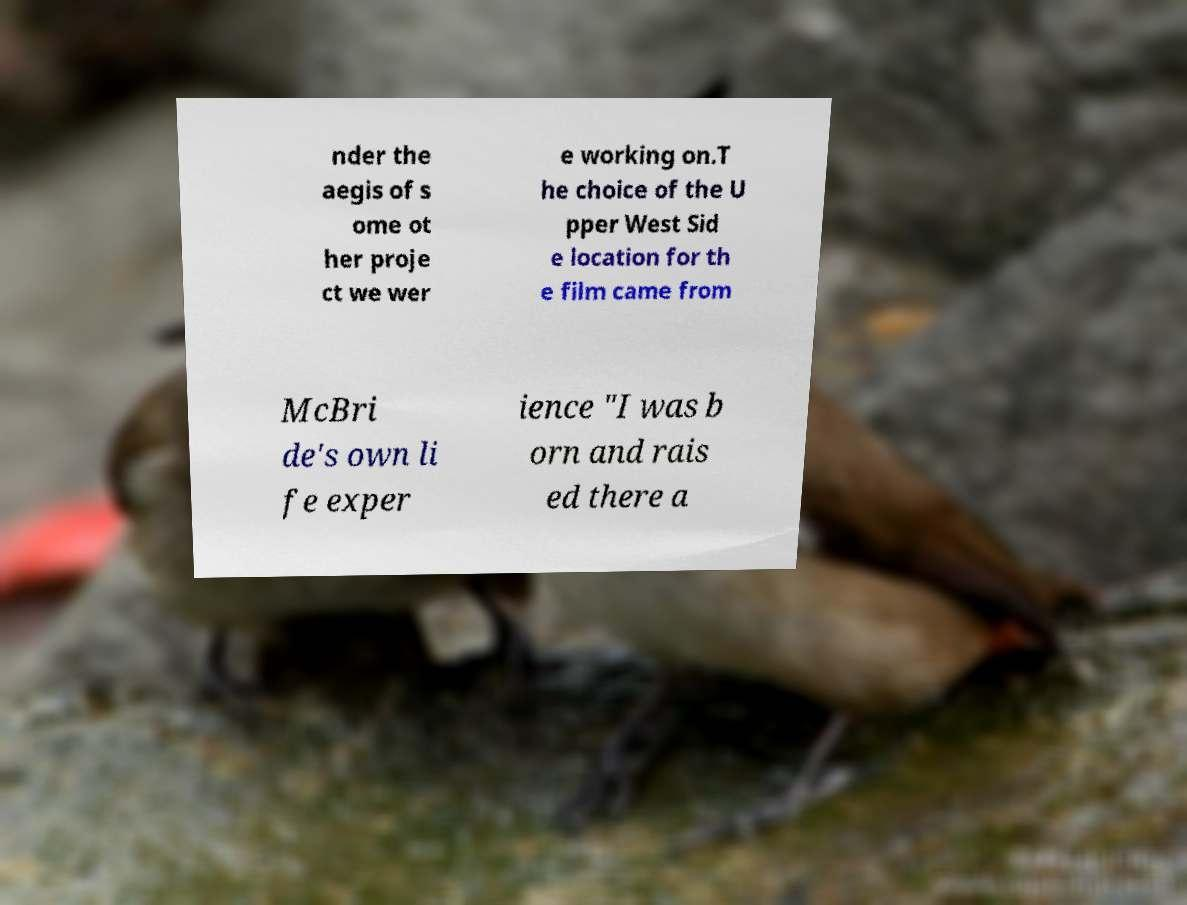I need the written content from this picture converted into text. Can you do that? nder the aegis of s ome ot her proje ct we wer e working on.T he choice of the U pper West Sid e location for th e film came from McBri de's own li fe exper ience "I was b orn and rais ed there a 